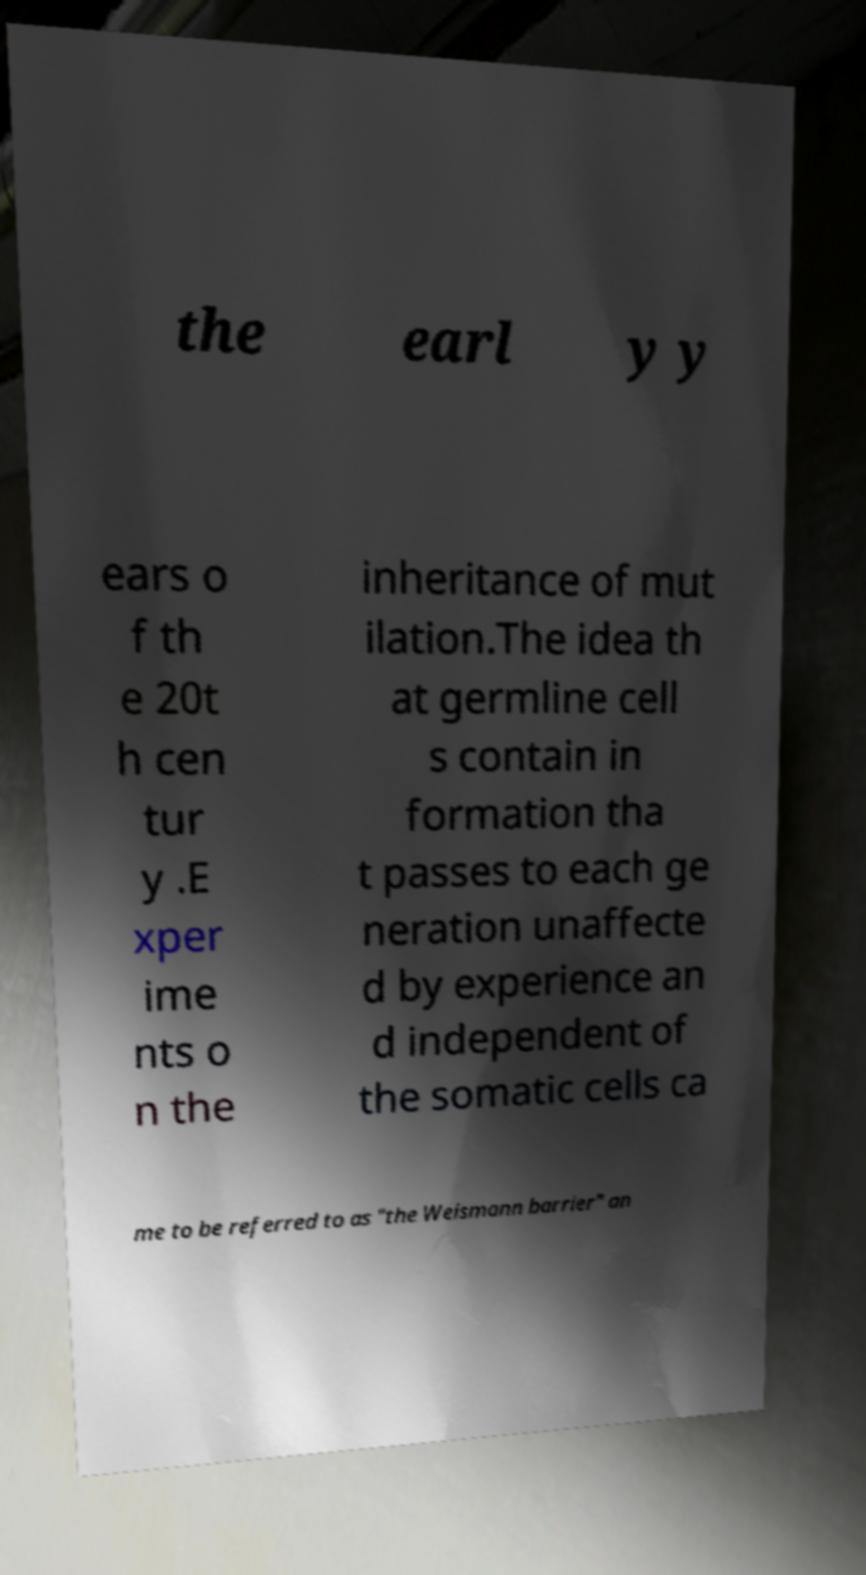Could you extract and type out the text from this image? the earl y y ears o f th e 20t h cen tur y .E xper ime nts o n the inheritance of mut ilation.The idea th at germline cell s contain in formation tha t passes to each ge neration unaffecte d by experience an d independent of the somatic cells ca me to be referred to as "the Weismann barrier" an 